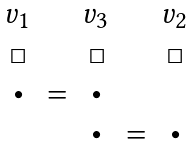<formula> <loc_0><loc_0><loc_500><loc_500>\begin{array} { c c c c c c } v _ { 1 } & & v _ { 3 } & & v _ { 2 } \\ \Box & & \Box & & \Box \\ \bullet & = & \bullet & & \\ & & \bullet & = & \bullet \end{array}</formula> 